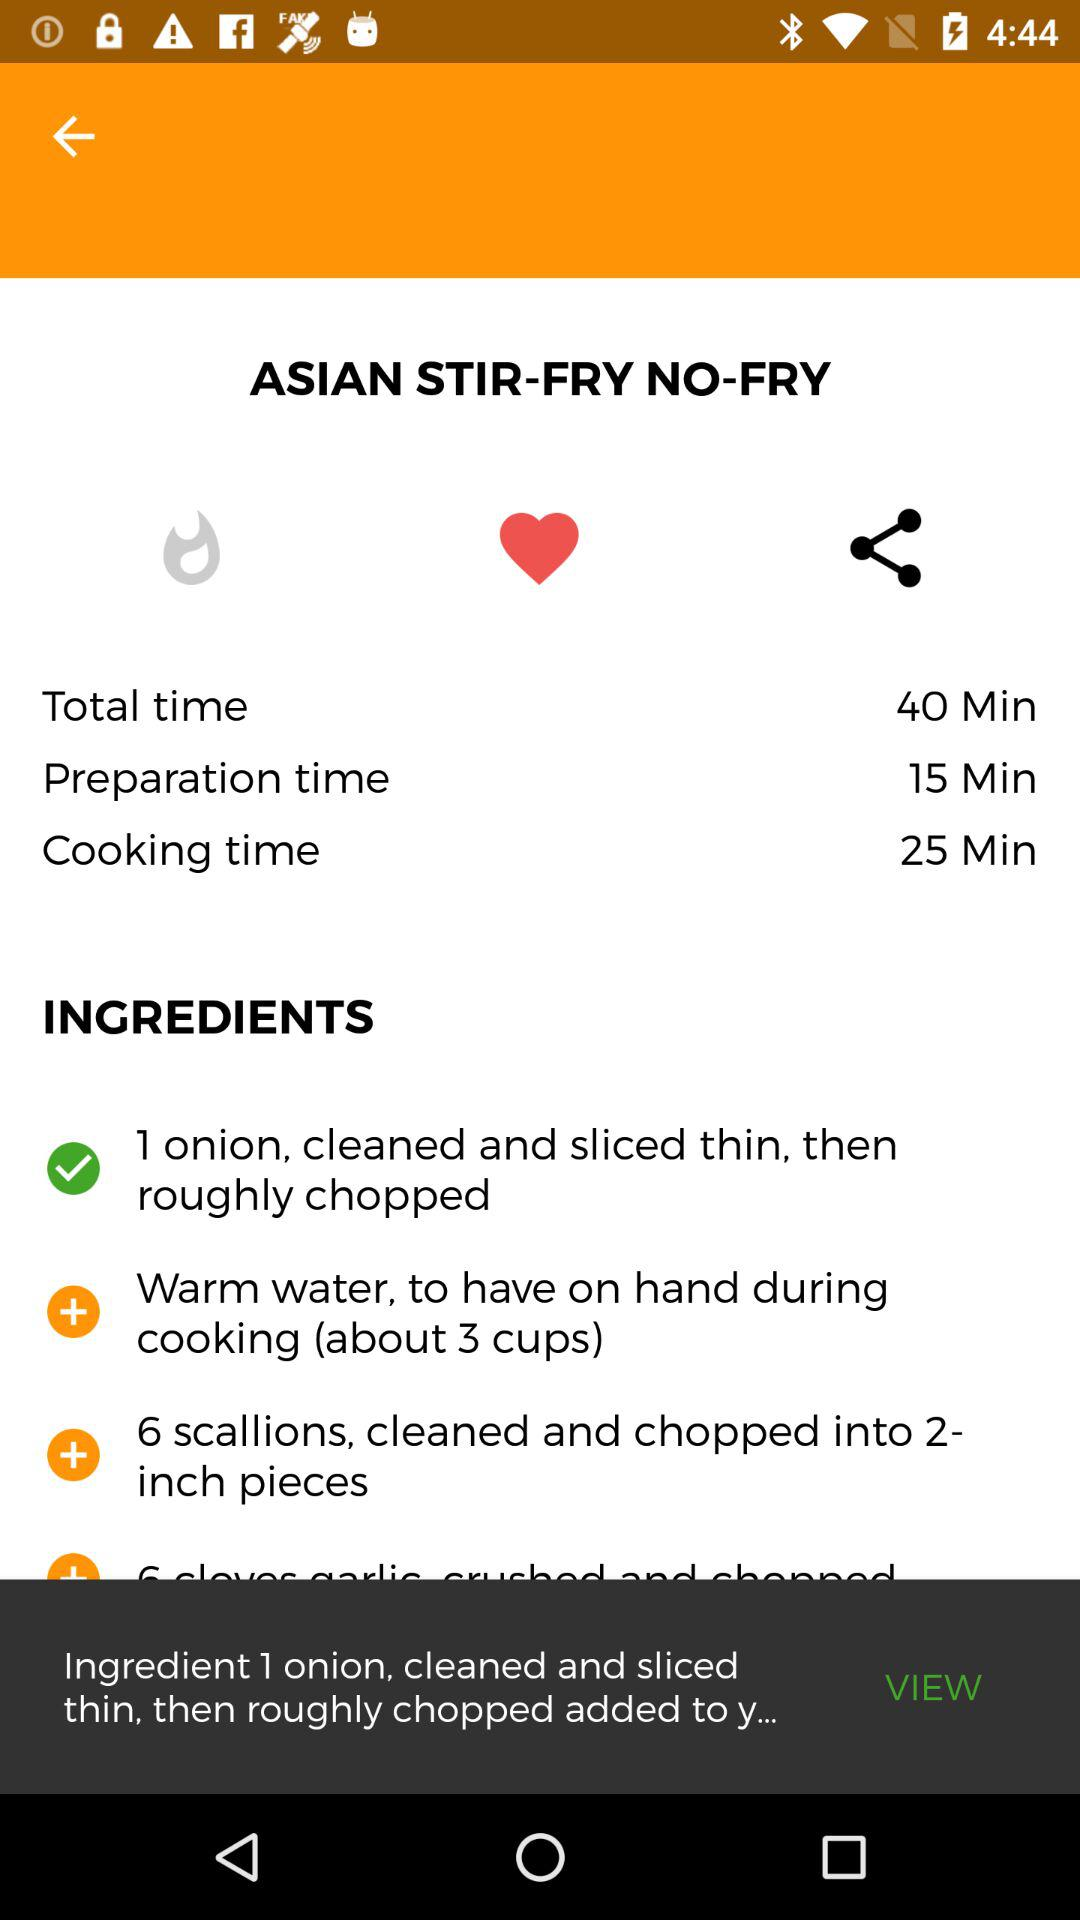What are the ingredients? The ingredients are 1 onion, cleaned and thinly sliced, then roughly chopped, 3 cups warm water to have on hand while cooking, and 6 scallions, cleaned and chopped into 2-inch pieces. 